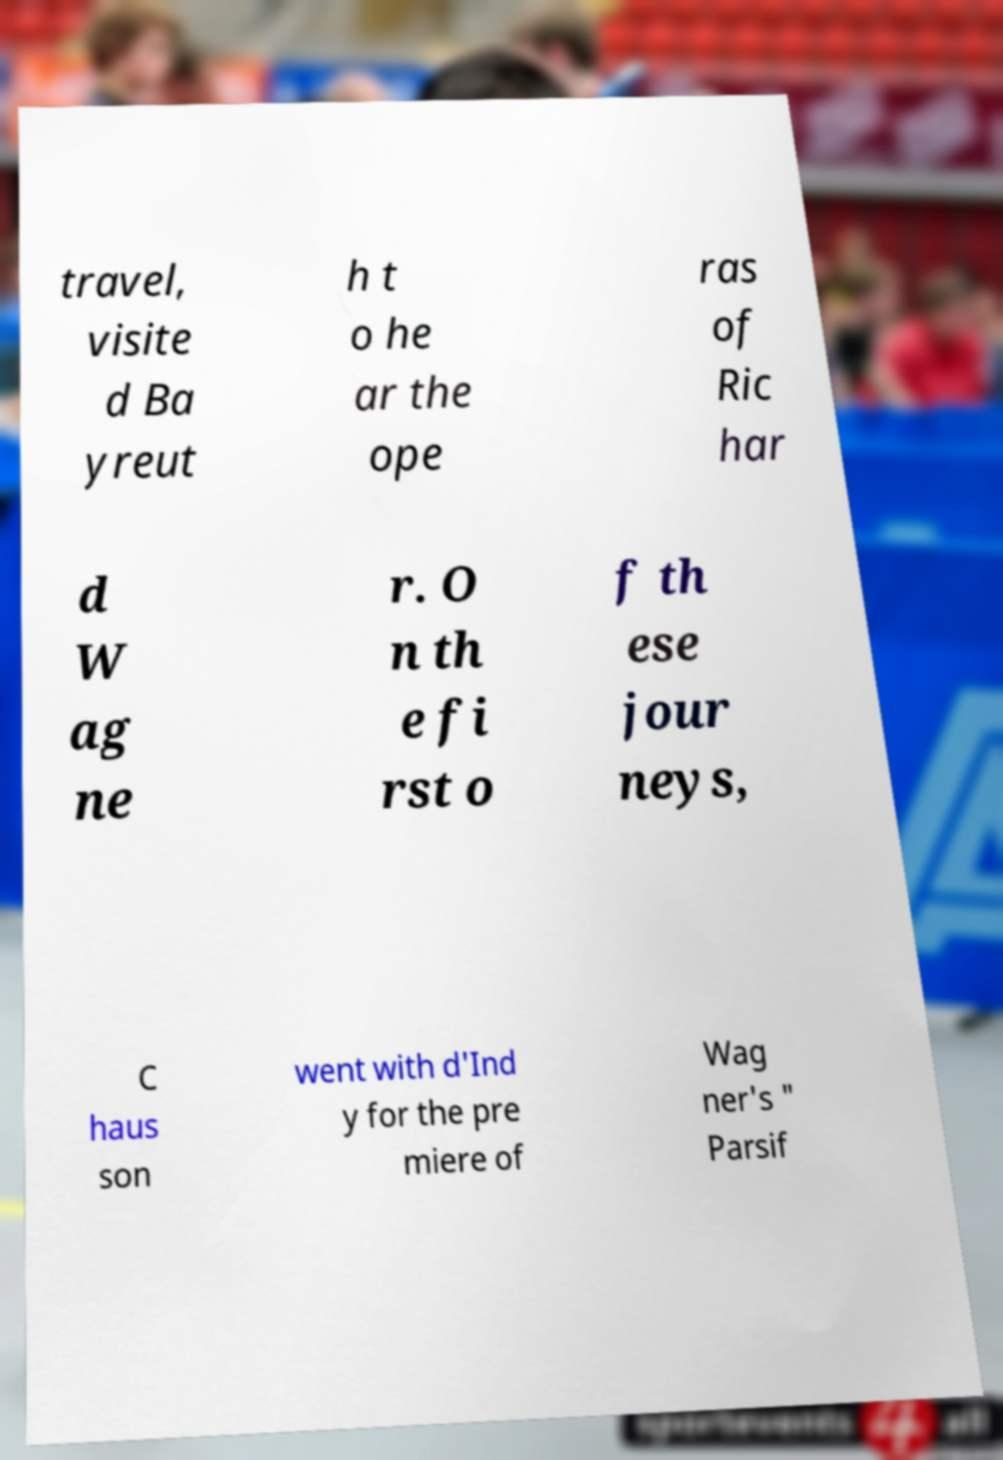Please identify and transcribe the text found in this image. travel, visite d Ba yreut h t o he ar the ope ras of Ric har d W ag ne r. O n th e fi rst o f th ese jour neys, C haus son went with d'Ind y for the pre miere of Wag ner's " Parsif 